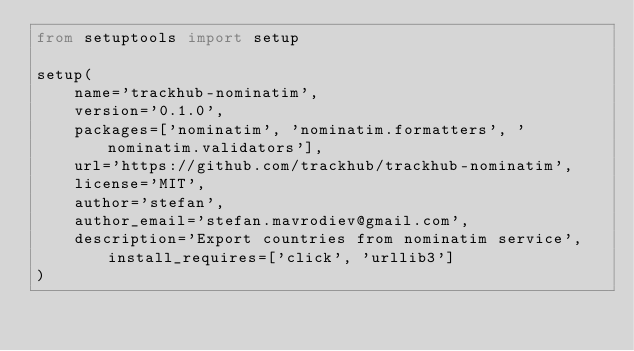Convert code to text. <code><loc_0><loc_0><loc_500><loc_500><_Python_>from setuptools import setup

setup(
    name='trackhub-nominatim',
    version='0.1.0',
    packages=['nominatim', 'nominatim.formatters', 'nominatim.validators'],
    url='https://github.com/trackhub/trackhub-nominatim',
    license='MIT',
    author='stefan',
    author_email='stefan.mavrodiev@gmail.com',
    description='Export countries from nominatim service', install_requires=['click', 'urllib3']
)
</code> 